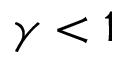Convert formula to latex. <formula><loc_0><loc_0><loc_500><loc_500>\gamma < 1</formula> 